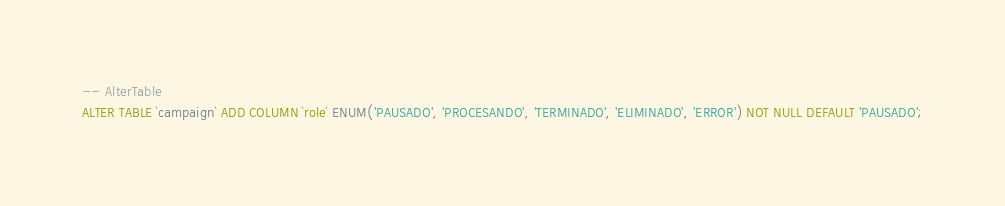Convert code to text. <code><loc_0><loc_0><loc_500><loc_500><_SQL_>-- AlterTable
ALTER TABLE `campaign` ADD COLUMN `role` ENUM('PAUSADO', 'PROCESANDO', 'TERMINADO', 'ELIMINADO', 'ERROR') NOT NULL DEFAULT 'PAUSADO';
</code> 